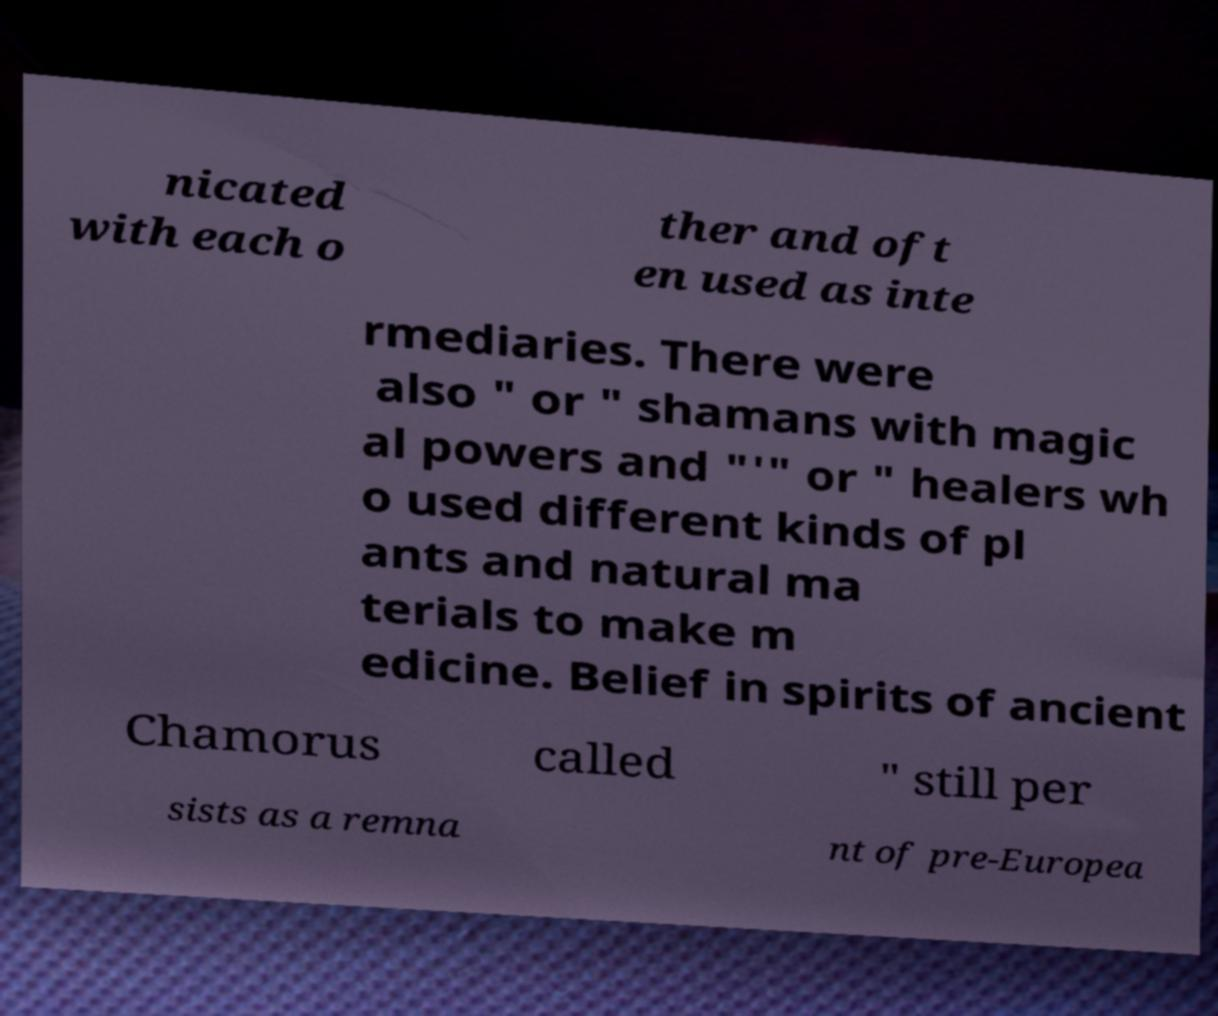Please identify and transcribe the text found in this image. nicated with each o ther and oft en used as inte rmediaries. There were also " or " shamans with magic al powers and "'" or " healers wh o used different kinds of pl ants and natural ma terials to make m edicine. Belief in spirits of ancient Chamorus called " still per sists as a remna nt of pre-Europea 